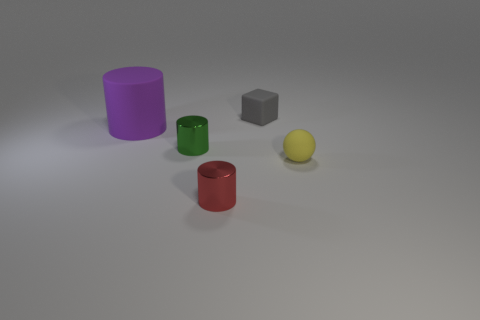How many cylinders are in front of the small cylinder that is in front of the tiny cylinder left of the tiny red metal cylinder?
Make the answer very short. 0. Is the number of rubber cylinders that are in front of the small yellow thing less than the number of small cyan cylinders?
Provide a short and direct response. No. Is there anything else that is the same shape as the large rubber thing?
Ensure brevity in your answer.  Yes. There is a tiny metallic thing behind the small yellow ball; what shape is it?
Offer a very short reply. Cylinder. There is a metal thing left of the metal cylinder that is in front of the shiny cylinder that is left of the tiny red shiny cylinder; what is its shape?
Give a very brief answer. Cylinder. What number of things are either balls or small gray rubber cubes?
Make the answer very short. 2. There is a rubber thing that is on the left side of the gray cube; is it the same shape as the metallic object that is behind the yellow object?
Your answer should be very brief. Yes. What number of tiny objects are both behind the red thing and to the left of the yellow matte object?
Your answer should be very brief. 2. How many other things are there of the same size as the purple object?
Provide a succinct answer. 0. What is the tiny object that is behind the small yellow ball and left of the gray rubber thing made of?
Give a very brief answer. Metal. 